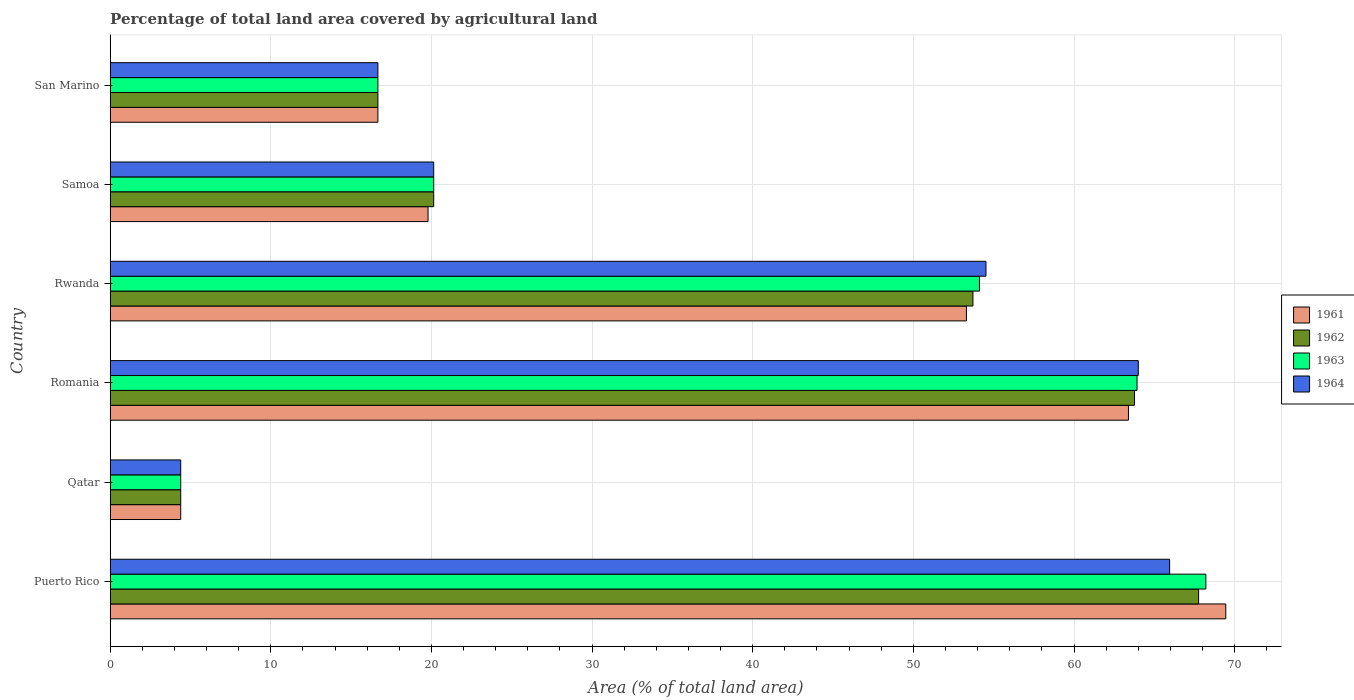Are the number of bars per tick equal to the number of legend labels?
Your answer should be compact. Yes. Are the number of bars on each tick of the Y-axis equal?
Your answer should be compact. Yes. How many bars are there on the 4th tick from the top?
Offer a very short reply. 4. What is the label of the 1st group of bars from the top?
Make the answer very short. San Marino. In how many cases, is the number of bars for a given country not equal to the number of legend labels?
Ensure brevity in your answer.  0. What is the percentage of agricultural land in 1961 in Rwanda?
Your response must be concise. 53.3. Across all countries, what is the maximum percentage of agricultural land in 1961?
Provide a succinct answer. 69.45. Across all countries, what is the minimum percentage of agricultural land in 1964?
Provide a succinct answer. 4.39. In which country was the percentage of agricultural land in 1964 maximum?
Your answer should be compact. Puerto Rico. In which country was the percentage of agricultural land in 1964 minimum?
Make the answer very short. Qatar. What is the total percentage of agricultural land in 1962 in the graph?
Your answer should be compact. 226.43. What is the difference between the percentage of agricultural land in 1962 in Puerto Rico and that in Romania?
Give a very brief answer. 3.99. What is the difference between the percentage of agricultural land in 1961 in Romania and the percentage of agricultural land in 1964 in Samoa?
Provide a short and direct response. 43.25. What is the average percentage of agricultural land in 1962 per country?
Your answer should be compact. 37.74. What is the difference between the percentage of agricultural land in 1961 and percentage of agricultural land in 1964 in Puerto Rico?
Your answer should be compact. 3.49. What is the ratio of the percentage of agricultural land in 1962 in Romania to that in Rwanda?
Keep it short and to the point. 1.19. Is the difference between the percentage of agricultural land in 1961 in Puerto Rico and Samoa greater than the difference between the percentage of agricultural land in 1964 in Puerto Rico and Samoa?
Make the answer very short. Yes. What is the difference between the highest and the second highest percentage of agricultural land in 1961?
Offer a very short reply. 6.06. What is the difference between the highest and the lowest percentage of agricultural land in 1963?
Your answer should be very brief. 63.81. What does the 1st bar from the top in Qatar represents?
Make the answer very short. 1964. What does the 1st bar from the bottom in Rwanda represents?
Give a very brief answer. 1961. How many bars are there?
Offer a very short reply. 24. Are all the bars in the graph horizontal?
Provide a short and direct response. Yes. How many countries are there in the graph?
Provide a short and direct response. 6. What is the difference between two consecutive major ticks on the X-axis?
Offer a very short reply. 10. Are the values on the major ticks of X-axis written in scientific E-notation?
Your answer should be very brief. No. Does the graph contain any zero values?
Give a very brief answer. No. Does the graph contain grids?
Your answer should be compact. Yes. Where does the legend appear in the graph?
Keep it short and to the point. Center right. How many legend labels are there?
Provide a succinct answer. 4. How are the legend labels stacked?
Offer a terse response. Vertical. What is the title of the graph?
Make the answer very short. Percentage of total land area covered by agricultural land. What is the label or title of the X-axis?
Offer a very short reply. Area (% of total land area). What is the label or title of the Y-axis?
Provide a short and direct response. Country. What is the Area (% of total land area) in 1961 in Puerto Rico?
Your response must be concise. 69.45. What is the Area (% of total land area) in 1962 in Puerto Rico?
Ensure brevity in your answer.  67.76. What is the Area (% of total land area) of 1963 in Puerto Rico?
Provide a short and direct response. 68.21. What is the Area (% of total land area) in 1964 in Puerto Rico?
Provide a succinct answer. 65.95. What is the Area (% of total land area) in 1961 in Qatar?
Provide a short and direct response. 4.39. What is the Area (% of total land area) of 1962 in Qatar?
Your answer should be very brief. 4.39. What is the Area (% of total land area) in 1963 in Qatar?
Keep it short and to the point. 4.39. What is the Area (% of total land area) in 1964 in Qatar?
Make the answer very short. 4.39. What is the Area (% of total land area) of 1961 in Romania?
Your answer should be compact. 63.39. What is the Area (% of total land area) of 1962 in Romania?
Your response must be concise. 63.77. What is the Area (% of total land area) in 1963 in Romania?
Your answer should be compact. 63.92. What is the Area (% of total land area) of 1964 in Romania?
Your response must be concise. 64. What is the Area (% of total land area) in 1961 in Rwanda?
Give a very brief answer. 53.3. What is the Area (% of total land area) in 1962 in Rwanda?
Ensure brevity in your answer.  53.71. What is the Area (% of total land area) in 1963 in Rwanda?
Make the answer very short. 54.11. What is the Area (% of total land area) in 1964 in Rwanda?
Give a very brief answer. 54.52. What is the Area (% of total land area) of 1961 in Samoa?
Your response must be concise. 19.79. What is the Area (% of total land area) in 1962 in Samoa?
Your response must be concise. 20.14. What is the Area (% of total land area) in 1963 in Samoa?
Your answer should be compact. 20.14. What is the Area (% of total land area) in 1964 in Samoa?
Provide a short and direct response. 20.14. What is the Area (% of total land area) of 1961 in San Marino?
Make the answer very short. 16.67. What is the Area (% of total land area) of 1962 in San Marino?
Your answer should be very brief. 16.67. What is the Area (% of total land area) in 1963 in San Marino?
Make the answer very short. 16.67. What is the Area (% of total land area) of 1964 in San Marino?
Give a very brief answer. 16.67. Across all countries, what is the maximum Area (% of total land area) in 1961?
Keep it short and to the point. 69.45. Across all countries, what is the maximum Area (% of total land area) in 1962?
Offer a very short reply. 67.76. Across all countries, what is the maximum Area (% of total land area) of 1963?
Your answer should be very brief. 68.21. Across all countries, what is the maximum Area (% of total land area) in 1964?
Your answer should be very brief. 65.95. Across all countries, what is the minimum Area (% of total land area) in 1961?
Offer a very short reply. 4.39. Across all countries, what is the minimum Area (% of total land area) of 1962?
Give a very brief answer. 4.39. Across all countries, what is the minimum Area (% of total land area) in 1963?
Provide a short and direct response. 4.39. Across all countries, what is the minimum Area (% of total land area) of 1964?
Provide a short and direct response. 4.39. What is the total Area (% of total land area) in 1961 in the graph?
Your answer should be compact. 226.99. What is the total Area (% of total land area) in 1962 in the graph?
Provide a succinct answer. 226.43. What is the total Area (% of total land area) in 1963 in the graph?
Offer a terse response. 227.45. What is the total Area (% of total land area) of 1964 in the graph?
Provide a succinct answer. 225.67. What is the difference between the Area (% of total land area) of 1961 in Puerto Rico and that in Qatar?
Offer a very short reply. 65.05. What is the difference between the Area (% of total land area) of 1962 in Puerto Rico and that in Qatar?
Keep it short and to the point. 63.36. What is the difference between the Area (% of total land area) of 1963 in Puerto Rico and that in Qatar?
Your response must be concise. 63.81. What is the difference between the Area (% of total land area) of 1964 in Puerto Rico and that in Qatar?
Offer a very short reply. 61.56. What is the difference between the Area (% of total land area) in 1961 in Puerto Rico and that in Romania?
Your answer should be very brief. 6.06. What is the difference between the Area (% of total land area) of 1962 in Puerto Rico and that in Romania?
Offer a terse response. 3.99. What is the difference between the Area (% of total land area) of 1963 in Puerto Rico and that in Romania?
Give a very brief answer. 4.28. What is the difference between the Area (% of total land area) of 1964 in Puerto Rico and that in Romania?
Provide a short and direct response. 1.95. What is the difference between the Area (% of total land area) in 1961 in Puerto Rico and that in Rwanda?
Your answer should be compact. 16.14. What is the difference between the Area (% of total land area) of 1962 in Puerto Rico and that in Rwanda?
Provide a short and direct response. 14.05. What is the difference between the Area (% of total land area) of 1963 in Puerto Rico and that in Rwanda?
Keep it short and to the point. 14.09. What is the difference between the Area (% of total land area) in 1964 in Puerto Rico and that in Rwanda?
Keep it short and to the point. 11.43. What is the difference between the Area (% of total land area) of 1961 in Puerto Rico and that in Samoa?
Offer a terse response. 49.66. What is the difference between the Area (% of total land area) in 1962 in Puerto Rico and that in Samoa?
Offer a terse response. 47.62. What is the difference between the Area (% of total land area) in 1963 in Puerto Rico and that in Samoa?
Provide a short and direct response. 48.07. What is the difference between the Area (% of total land area) in 1964 in Puerto Rico and that in Samoa?
Make the answer very short. 45.81. What is the difference between the Area (% of total land area) of 1961 in Puerto Rico and that in San Marino?
Make the answer very short. 52.78. What is the difference between the Area (% of total land area) in 1962 in Puerto Rico and that in San Marino?
Give a very brief answer. 51.09. What is the difference between the Area (% of total land area) of 1963 in Puerto Rico and that in San Marino?
Your answer should be compact. 51.54. What is the difference between the Area (% of total land area) in 1964 in Puerto Rico and that in San Marino?
Ensure brevity in your answer.  49.29. What is the difference between the Area (% of total land area) in 1961 in Qatar and that in Romania?
Offer a very short reply. -59. What is the difference between the Area (% of total land area) of 1962 in Qatar and that in Romania?
Ensure brevity in your answer.  -59.37. What is the difference between the Area (% of total land area) in 1963 in Qatar and that in Romania?
Your response must be concise. -59.53. What is the difference between the Area (% of total land area) in 1964 in Qatar and that in Romania?
Keep it short and to the point. -59.61. What is the difference between the Area (% of total land area) in 1961 in Qatar and that in Rwanda?
Provide a succinct answer. -48.91. What is the difference between the Area (% of total land area) of 1962 in Qatar and that in Rwanda?
Offer a terse response. -49.32. What is the difference between the Area (% of total land area) of 1963 in Qatar and that in Rwanda?
Keep it short and to the point. -49.72. What is the difference between the Area (% of total land area) of 1964 in Qatar and that in Rwanda?
Your answer should be compact. -50.13. What is the difference between the Area (% of total land area) in 1961 in Qatar and that in Samoa?
Your answer should be compact. -15.4. What is the difference between the Area (% of total land area) of 1962 in Qatar and that in Samoa?
Offer a terse response. -15.75. What is the difference between the Area (% of total land area) of 1963 in Qatar and that in Samoa?
Make the answer very short. -15.75. What is the difference between the Area (% of total land area) of 1964 in Qatar and that in Samoa?
Offer a very short reply. -15.75. What is the difference between the Area (% of total land area) in 1961 in Qatar and that in San Marino?
Make the answer very short. -12.27. What is the difference between the Area (% of total land area) in 1962 in Qatar and that in San Marino?
Make the answer very short. -12.27. What is the difference between the Area (% of total land area) in 1963 in Qatar and that in San Marino?
Your answer should be very brief. -12.27. What is the difference between the Area (% of total land area) of 1964 in Qatar and that in San Marino?
Your response must be concise. -12.27. What is the difference between the Area (% of total land area) in 1961 in Romania and that in Rwanda?
Your response must be concise. 10.09. What is the difference between the Area (% of total land area) of 1962 in Romania and that in Rwanda?
Your answer should be compact. 10.06. What is the difference between the Area (% of total land area) of 1963 in Romania and that in Rwanda?
Make the answer very short. 9.81. What is the difference between the Area (% of total land area) in 1964 in Romania and that in Rwanda?
Your answer should be very brief. 9.48. What is the difference between the Area (% of total land area) in 1961 in Romania and that in Samoa?
Provide a short and direct response. 43.6. What is the difference between the Area (% of total land area) in 1962 in Romania and that in Samoa?
Provide a succinct answer. 43.63. What is the difference between the Area (% of total land area) of 1963 in Romania and that in Samoa?
Give a very brief answer. 43.78. What is the difference between the Area (% of total land area) in 1964 in Romania and that in Samoa?
Your answer should be compact. 43.86. What is the difference between the Area (% of total land area) of 1961 in Romania and that in San Marino?
Offer a very short reply. 46.72. What is the difference between the Area (% of total land area) of 1962 in Romania and that in San Marino?
Your answer should be compact. 47.1. What is the difference between the Area (% of total land area) in 1963 in Romania and that in San Marino?
Give a very brief answer. 47.26. What is the difference between the Area (% of total land area) of 1964 in Romania and that in San Marino?
Give a very brief answer. 47.33. What is the difference between the Area (% of total land area) in 1961 in Rwanda and that in Samoa?
Keep it short and to the point. 33.52. What is the difference between the Area (% of total land area) of 1962 in Rwanda and that in Samoa?
Provide a short and direct response. 33.57. What is the difference between the Area (% of total land area) in 1963 in Rwanda and that in Samoa?
Ensure brevity in your answer.  33.97. What is the difference between the Area (% of total land area) in 1964 in Rwanda and that in Samoa?
Make the answer very short. 34.38. What is the difference between the Area (% of total land area) of 1961 in Rwanda and that in San Marino?
Your answer should be compact. 36.64. What is the difference between the Area (% of total land area) in 1962 in Rwanda and that in San Marino?
Your answer should be compact. 37.04. What is the difference between the Area (% of total land area) in 1963 in Rwanda and that in San Marino?
Ensure brevity in your answer.  37.45. What is the difference between the Area (% of total land area) of 1964 in Rwanda and that in San Marino?
Keep it short and to the point. 37.85. What is the difference between the Area (% of total land area) of 1961 in Samoa and that in San Marino?
Offer a very short reply. 3.12. What is the difference between the Area (% of total land area) in 1962 in Samoa and that in San Marino?
Give a very brief answer. 3.47. What is the difference between the Area (% of total land area) in 1963 in Samoa and that in San Marino?
Give a very brief answer. 3.47. What is the difference between the Area (% of total land area) of 1964 in Samoa and that in San Marino?
Your answer should be compact. 3.47. What is the difference between the Area (% of total land area) in 1961 in Puerto Rico and the Area (% of total land area) in 1962 in Qatar?
Give a very brief answer. 65.05. What is the difference between the Area (% of total land area) in 1961 in Puerto Rico and the Area (% of total land area) in 1963 in Qatar?
Give a very brief answer. 65.05. What is the difference between the Area (% of total land area) of 1961 in Puerto Rico and the Area (% of total land area) of 1964 in Qatar?
Your answer should be very brief. 65.05. What is the difference between the Area (% of total land area) of 1962 in Puerto Rico and the Area (% of total land area) of 1963 in Qatar?
Provide a succinct answer. 63.36. What is the difference between the Area (% of total land area) in 1962 in Puerto Rico and the Area (% of total land area) in 1964 in Qatar?
Your response must be concise. 63.36. What is the difference between the Area (% of total land area) in 1963 in Puerto Rico and the Area (% of total land area) in 1964 in Qatar?
Make the answer very short. 63.81. What is the difference between the Area (% of total land area) of 1961 in Puerto Rico and the Area (% of total land area) of 1962 in Romania?
Your answer should be compact. 5.68. What is the difference between the Area (% of total land area) of 1961 in Puerto Rico and the Area (% of total land area) of 1963 in Romania?
Keep it short and to the point. 5.52. What is the difference between the Area (% of total land area) in 1961 in Puerto Rico and the Area (% of total land area) in 1964 in Romania?
Offer a very short reply. 5.45. What is the difference between the Area (% of total land area) of 1962 in Puerto Rico and the Area (% of total land area) of 1963 in Romania?
Offer a terse response. 3.83. What is the difference between the Area (% of total land area) of 1962 in Puerto Rico and the Area (% of total land area) of 1964 in Romania?
Give a very brief answer. 3.76. What is the difference between the Area (% of total land area) of 1963 in Puerto Rico and the Area (% of total land area) of 1964 in Romania?
Provide a succinct answer. 4.21. What is the difference between the Area (% of total land area) in 1961 in Puerto Rico and the Area (% of total land area) in 1962 in Rwanda?
Offer a very short reply. 15.74. What is the difference between the Area (% of total land area) in 1961 in Puerto Rico and the Area (% of total land area) in 1963 in Rwanda?
Offer a terse response. 15.33. What is the difference between the Area (% of total land area) in 1961 in Puerto Rico and the Area (% of total land area) in 1964 in Rwanda?
Your answer should be compact. 14.93. What is the difference between the Area (% of total land area) of 1962 in Puerto Rico and the Area (% of total land area) of 1963 in Rwanda?
Give a very brief answer. 13.64. What is the difference between the Area (% of total land area) of 1962 in Puerto Rico and the Area (% of total land area) of 1964 in Rwanda?
Your answer should be compact. 13.24. What is the difference between the Area (% of total land area) of 1963 in Puerto Rico and the Area (% of total land area) of 1964 in Rwanda?
Make the answer very short. 13.69. What is the difference between the Area (% of total land area) of 1961 in Puerto Rico and the Area (% of total land area) of 1962 in Samoa?
Provide a short and direct response. 49.31. What is the difference between the Area (% of total land area) in 1961 in Puerto Rico and the Area (% of total land area) in 1963 in Samoa?
Make the answer very short. 49.31. What is the difference between the Area (% of total land area) in 1961 in Puerto Rico and the Area (% of total land area) in 1964 in Samoa?
Give a very brief answer. 49.31. What is the difference between the Area (% of total land area) in 1962 in Puerto Rico and the Area (% of total land area) in 1963 in Samoa?
Your answer should be compact. 47.62. What is the difference between the Area (% of total land area) of 1962 in Puerto Rico and the Area (% of total land area) of 1964 in Samoa?
Your response must be concise. 47.62. What is the difference between the Area (% of total land area) in 1963 in Puerto Rico and the Area (% of total land area) in 1964 in Samoa?
Offer a very short reply. 48.07. What is the difference between the Area (% of total land area) of 1961 in Puerto Rico and the Area (% of total land area) of 1962 in San Marino?
Provide a short and direct response. 52.78. What is the difference between the Area (% of total land area) in 1961 in Puerto Rico and the Area (% of total land area) in 1963 in San Marino?
Make the answer very short. 52.78. What is the difference between the Area (% of total land area) of 1961 in Puerto Rico and the Area (% of total land area) of 1964 in San Marino?
Ensure brevity in your answer.  52.78. What is the difference between the Area (% of total land area) of 1962 in Puerto Rico and the Area (% of total land area) of 1963 in San Marino?
Provide a succinct answer. 51.09. What is the difference between the Area (% of total land area) of 1962 in Puerto Rico and the Area (% of total land area) of 1964 in San Marino?
Offer a terse response. 51.09. What is the difference between the Area (% of total land area) of 1963 in Puerto Rico and the Area (% of total land area) of 1964 in San Marino?
Your answer should be very brief. 51.54. What is the difference between the Area (% of total land area) in 1961 in Qatar and the Area (% of total land area) in 1962 in Romania?
Ensure brevity in your answer.  -59.37. What is the difference between the Area (% of total land area) of 1961 in Qatar and the Area (% of total land area) of 1963 in Romania?
Offer a very short reply. -59.53. What is the difference between the Area (% of total land area) in 1961 in Qatar and the Area (% of total land area) in 1964 in Romania?
Your answer should be compact. -59.61. What is the difference between the Area (% of total land area) of 1962 in Qatar and the Area (% of total land area) of 1963 in Romania?
Offer a very short reply. -59.53. What is the difference between the Area (% of total land area) of 1962 in Qatar and the Area (% of total land area) of 1964 in Romania?
Give a very brief answer. -59.61. What is the difference between the Area (% of total land area) of 1963 in Qatar and the Area (% of total land area) of 1964 in Romania?
Give a very brief answer. -59.61. What is the difference between the Area (% of total land area) of 1961 in Qatar and the Area (% of total land area) of 1962 in Rwanda?
Offer a terse response. -49.32. What is the difference between the Area (% of total land area) in 1961 in Qatar and the Area (% of total land area) in 1963 in Rwanda?
Ensure brevity in your answer.  -49.72. What is the difference between the Area (% of total land area) in 1961 in Qatar and the Area (% of total land area) in 1964 in Rwanda?
Provide a succinct answer. -50.13. What is the difference between the Area (% of total land area) of 1962 in Qatar and the Area (% of total land area) of 1963 in Rwanda?
Keep it short and to the point. -49.72. What is the difference between the Area (% of total land area) of 1962 in Qatar and the Area (% of total land area) of 1964 in Rwanda?
Your response must be concise. -50.13. What is the difference between the Area (% of total land area) in 1963 in Qatar and the Area (% of total land area) in 1964 in Rwanda?
Your response must be concise. -50.13. What is the difference between the Area (% of total land area) of 1961 in Qatar and the Area (% of total land area) of 1962 in Samoa?
Your answer should be very brief. -15.75. What is the difference between the Area (% of total land area) of 1961 in Qatar and the Area (% of total land area) of 1963 in Samoa?
Make the answer very short. -15.75. What is the difference between the Area (% of total land area) of 1961 in Qatar and the Area (% of total land area) of 1964 in Samoa?
Offer a terse response. -15.75. What is the difference between the Area (% of total land area) of 1962 in Qatar and the Area (% of total land area) of 1963 in Samoa?
Your response must be concise. -15.75. What is the difference between the Area (% of total land area) of 1962 in Qatar and the Area (% of total land area) of 1964 in Samoa?
Ensure brevity in your answer.  -15.75. What is the difference between the Area (% of total land area) of 1963 in Qatar and the Area (% of total land area) of 1964 in Samoa?
Give a very brief answer. -15.75. What is the difference between the Area (% of total land area) of 1961 in Qatar and the Area (% of total land area) of 1962 in San Marino?
Ensure brevity in your answer.  -12.27. What is the difference between the Area (% of total land area) of 1961 in Qatar and the Area (% of total land area) of 1963 in San Marino?
Ensure brevity in your answer.  -12.27. What is the difference between the Area (% of total land area) of 1961 in Qatar and the Area (% of total land area) of 1964 in San Marino?
Your response must be concise. -12.27. What is the difference between the Area (% of total land area) in 1962 in Qatar and the Area (% of total land area) in 1963 in San Marino?
Offer a very short reply. -12.27. What is the difference between the Area (% of total land area) in 1962 in Qatar and the Area (% of total land area) in 1964 in San Marino?
Your answer should be very brief. -12.27. What is the difference between the Area (% of total land area) in 1963 in Qatar and the Area (% of total land area) in 1964 in San Marino?
Your answer should be compact. -12.27. What is the difference between the Area (% of total land area) in 1961 in Romania and the Area (% of total land area) in 1962 in Rwanda?
Your response must be concise. 9.68. What is the difference between the Area (% of total land area) of 1961 in Romania and the Area (% of total land area) of 1963 in Rwanda?
Give a very brief answer. 9.27. What is the difference between the Area (% of total land area) of 1961 in Romania and the Area (% of total land area) of 1964 in Rwanda?
Your answer should be very brief. 8.87. What is the difference between the Area (% of total land area) of 1962 in Romania and the Area (% of total land area) of 1963 in Rwanda?
Make the answer very short. 9.65. What is the difference between the Area (% of total land area) in 1962 in Romania and the Area (% of total land area) in 1964 in Rwanda?
Provide a short and direct response. 9.25. What is the difference between the Area (% of total land area) of 1963 in Romania and the Area (% of total land area) of 1964 in Rwanda?
Provide a succinct answer. 9.4. What is the difference between the Area (% of total land area) in 1961 in Romania and the Area (% of total land area) in 1962 in Samoa?
Give a very brief answer. 43.25. What is the difference between the Area (% of total land area) in 1961 in Romania and the Area (% of total land area) in 1963 in Samoa?
Give a very brief answer. 43.25. What is the difference between the Area (% of total land area) in 1961 in Romania and the Area (% of total land area) in 1964 in Samoa?
Your answer should be very brief. 43.25. What is the difference between the Area (% of total land area) in 1962 in Romania and the Area (% of total land area) in 1963 in Samoa?
Provide a short and direct response. 43.63. What is the difference between the Area (% of total land area) in 1962 in Romania and the Area (% of total land area) in 1964 in Samoa?
Ensure brevity in your answer.  43.63. What is the difference between the Area (% of total land area) in 1963 in Romania and the Area (% of total land area) in 1964 in Samoa?
Keep it short and to the point. 43.78. What is the difference between the Area (% of total land area) in 1961 in Romania and the Area (% of total land area) in 1962 in San Marino?
Offer a terse response. 46.72. What is the difference between the Area (% of total land area) of 1961 in Romania and the Area (% of total land area) of 1963 in San Marino?
Provide a short and direct response. 46.72. What is the difference between the Area (% of total land area) in 1961 in Romania and the Area (% of total land area) in 1964 in San Marino?
Provide a short and direct response. 46.72. What is the difference between the Area (% of total land area) of 1962 in Romania and the Area (% of total land area) of 1963 in San Marino?
Keep it short and to the point. 47.1. What is the difference between the Area (% of total land area) of 1962 in Romania and the Area (% of total land area) of 1964 in San Marino?
Ensure brevity in your answer.  47.1. What is the difference between the Area (% of total land area) of 1963 in Romania and the Area (% of total land area) of 1964 in San Marino?
Offer a terse response. 47.26. What is the difference between the Area (% of total land area) in 1961 in Rwanda and the Area (% of total land area) in 1962 in Samoa?
Keep it short and to the point. 33.16. What is the difference between the Area (% of total land area) of 1961 in Rwanda and the Area (% of total land area) of 1963 in Samoa?
Give a very brief answer. 33.16. What is the difference between the Area (% of total land area) in 1961 in Rwanda and the Area (% of total land area) in 1964 in Samoa?
Your answer should be very brief. 33.16. What is the difference between the Area (% of total land area) of 1962 in Rwanda and the Area (% of total land area) of 1963 in Samoa?
Give a very brief answer. 33.57. What is the difference between the Area (% of total land area) of 1962 in Rwanda and the Area (% of total land area) of 1964 in Samoa?
Your response must be concise. 33.57. What is the difference between the Area (% of total land area) of 1963 in Rwanda and the Area (% of total land area) of 1964 in Samoa?
Ensure brevity in your answer.  33.97. What is the difference between the Area (% of total land area) of 1961 in Rwanda and the Area (% of total land area) of 1962 in San Marino?
Provide a succinct answer. 36.64. What is the difference between the Area (% of total land area) of 1961 in Rwanda and the Area (% of total land area) of 1963 in San Marino?
Make the answer very short. 36.64. What is the difference between the Area (% of total land area) of 1961 in Rwanda and the Area (% of total land area) of 1964 in San Marino?
Offer a terse response. 36.64. What is the difference between the Area (% of total land area) in 1962 in Rwanda and the Area (% of total land area) in 1963 in San Marino?
Your answer should be compact. 37.04. What is the difference between the Area (% of total land area) of 1962 in Rwanda and the Area (% of total land area) of 1964 in San Marino?
Give a very brief answer. 37.04. What is the difference between the Area (% of total land area) in 1963 in Rwanda and the Area (% of total land area) in 1964 in San Marino?
Offer a terse response. 37.45. What is the difference between the Area (% of total land area) in 1961 in Samoa and the Area (% of total land area) in 1962 in San Marino?
Provide a short and direct response. 3.12. What is the difference between the Area (% of total land area) of 1961 in Samoa and the Area (% of total land area) of 1963 in San Marino?
Offer a terse response. 3.12. What is the difference between the Area (% of total land area) of 1961 in Samoa and the Area (% of total land area) of 1964 in San Marino?
Provide a short and direct response. 3.12. What is the difference between the Area (% of total land area) in 1962 in Samoa and the Area (% of total land area) in 1963 in San Marino?
Ensure brevity in your answer.  3.47. What is the difference between the Area (% of total land area) in 1962 in Samoa and the Area (% of total land area) in 1964 in San Marino?
Offer a very short reply. 3.47. What is the difference between the Area (% of total land area) of 1963 in Samoa and the Area (% of total land area) of 1964 in San Marino?
Ensure brevity in your answer.  3.47. What is the average Area (% of total land area) in 1961 per country?
Your answer should be compact. 37.83. What is the average Area (% of total land area) of 1962 per country?
Provide a succinct answer. 37.74. What is the average Area (% of total land area) in 1963 per country?
Offer a very short reply. 37.91. What is the average Area (% of total land area) of 1964 per country?
Offer a very short reply. 37.61. What is the difference between the Area (% of total land area) in 1961 and Area (% of total land area) in 1962 in Puerto Rico?
Your answer should be compact. 1.69. What is the difference between the Area (% of total land area) in 1961 and Area (% of total land area) in 1963 in Puerto Rico?
Your response must be concise. 1.24. What is the difference between the Area (% of total land area) of 1961 and Area (% of total land area) of 1964 in Puerto Rico?
Give a very brief answer. 3.49. What is the difference between the Area (% of total land area) in 1962 and Area (% of total land area) in 1963 in Puerto Rico?
Keep it short and to the point. -0.45. What is the difference between the Area (% of total land area) of 1962 and Area (% of total land area) of 1964 in Puerto Rico?
Provide a succinct answer. 1.8. What is the difference between the Area (% of total land area) of 1963 and Area (% of total land area) of 1964 in Puerto Rico?
Ensure brevity in your answer.  2.25. What is the difference between the Area (% of total land area) of 1961 and Area (% of total land area) of 1962 in Qatar?
Your answer should be very brief. 0. What is the difference between the Area (% of total land area) of 1961 and Area (% of total land area) of 1963 in Qatar?
Give a very brief answer. 0. What is the difference between the Area (% of total land area) of 1961 and Area (% of total land area) of 1964 in Qatar?
Give a very brief answer. 0. What is the difference between the Area (% of total land area) in 1961 and Area (% of total land area) in 1962 in Romania?
Your answer should be very brief. -0.38. What is the difference between the Area (% of total land area) of 1961 and Area (% of total land area) of 1963 in Romania?
Offer a terse response. -0.53. What is the difference between the Area (% of total land area) in 1961 and Area (% of total land area) in 1964 in Romania?
Your response must be concise. -0.61. What is the difference between the Area (% of total land area) of 1962 and Area (% of total land area) of 1963 in Romania?
Keep it short and to the point. -0.16. What is the difference between the Area (% of total land area) of 1962 and Area (% of total land area) of 1964 in Romania?
Provide a short and direct response. -0.23. What is the difference between the Area (% of total land area) of 1963 and Area (% of total land area) of 1964 in Romania?
Keep it short and to the point. -0.08. What is the difference between the Area (% of total land area) in 1961 and Area (% of total land area) in 1962 in Rwanda?
Make the answer very short. -0.41. What is the difference between the Area (% of total land area) in 1961 and Area (% of total land area) in 1963 in Rwanda?
Provide a succinct answer. -0.81. What is the difference between the Area (% of total land area) in 1961 and Area (% of total land area) in 1964 in Rwanda?
Your response must be concise. -1.22. What is the difference between the Area (% of total land area) of 1962 and Area (% of total land area) of 1963 in Rwanda?
Ensure brevity in your answer.  -0.41. What is the difference between the Area (% of total land area) in 1962 and Area (% of total land area) in 1964 in Rwanda?
Provide a short and direct response. -0.81. What is the difference between the Area (% of total land area) of 1963 and Area (% of total land area) of 1964 in Rwanda?
Offer a terse response. -0.41. What is the difference between the Area (% of total land area) in 1961 and Area (% of total land area) in 1962 in Samoa?
Your response must be concise. -0.35. What is the difference between the Area (% of total land area) in 1961 and Area (% of total land area) in 1963 in Samoa?
Your answer should be compact. -0.35. What is the difference between the Area (% of total land area) of 1961 and Area (% of total land area) of 1964 in Samoa?
Provide a short and direct response. -0.35. What is the difference between the Area (% of total land area) of 1962 and Area (% of total land area) of 1964 in Samoa?
Your answer should be very brief. 0. What is the difference between the Area (% of total land area) of 1961 and Area (% of total land area) of 1962 in San Marino?
Ensure brevity in your answer.  0. What is the difference between the Area (% of total land area) of 1961 and Area (% of total land area) of 1963 in San Marino?
Make the answer very short. 0. What is the difference between the Area (% of total land area) of 1962 and Area (% of total land area) of 1964 in San Marino?
Make the answer very short. 0. What is the ratio of the Area (% of total land area) in 1961 in Puerto Rico to that in Qatar?
Make the answer very short. 15.81. What is the ratio of the Area (% of total land area) of 1962 in Puerto Rico to that in Qatar?
Your answer should be very brief. 15.42. What is the ratio of the Area (% of total land area) in 1963 in Puerto Rico to that in Qatar?
Ensure brevity in your answer.  15.53. What is the ratio of the Area (% of total land area) of 1964 in Puerto Rico to that in Qatar?
Your answer should be compact. 15.01. What is the ratio of the Area (% of total land area) of 1961 in Puerto Rico to that in Romania?
Your answer should be very brief. 1.1. What is the ratio of the Area (% of total land area) of 1962 in Puerto Rico to that in Romania?
Offer a very short reply. 1.06. What is the ratio of the Area (% of total land area) of 1963 in Puerto Rico to that in Romania?
Make the answer very short. 1.07. What is the ratio of the Area (% of total land area) of 1964 in Puerto Rico to that in Romania?
Your answer should be compact. 1.03. What is the ratio of the Area (% of total land area) of 1961 in Puerto Rico to that in Rwanda?
Give a very brief answer. 1.3. What is the ratio of the Area (% of total land area) of 1962 in Puerto Rico to that in Rwanda?
Your answer should be very brief. 1.26. What is the ratio of the Area (% of total land area) in 1963 in Puerto Rico to that in Rwanda?
Offer a terse response. 1.26. What is the ratio of the Area (% of total land area) in 1964 in Puerto Rico to that in Rwanda?
Make the answer very short. 1.21. What is the ratio of the Area (% of total land area) in 1961 in Puerto Rico to that in Samoa?
Provide a succinct answer. 3.51. What is the ratio of the Area (% of total land area) in 1962 in Puerto Rico to that in Samoa?
Keep it short and to the point. 3.36. What is the ratio of the Area (% of total land area) of 1963 in Puerto Rico to that in Samoa?
Make the answer very short. 3.39. What is the ratio of the Area (% of total land area) of 1964 in Puerto Rico to that in Samoa?
Your response must be concise. 3.27. What is the ratio of the Area (% of total land area) in 1961 in Puerto Rico to that in San Marino?
Keep it short and to the point. 4.17. What is the ratio of the Area (% of total land area) in 1962 in Puerto Rico to that in San Marino?
Offer a terse response. 4.07. What is the ratio of the Area (% of total land area) in 1963 in Puerto Rico to that in San Marino?
Ensure brevity in your answer.  4.09. What is the ratio of the Area (% of total land area) in 1964 in Puerto Rico to that in San Marino?
Make the answer very short. 3.96. What is the ratio of the Area (% of total land area) of 1961 in Qatar to that in Romania?
Offer a terse response. 0.07. What is the ratio of the Area (% of total land area) in 1962 in Qatar to that in Romania?
Offer a very short reply. 0.07. What is the ratio of the Area (% of total land area) in 1963 in Qatar to that in Romania?
Keep it short and to the point. 0.07. What is the ratio of the Area (% of total land area) in 1964 in Qatar to that in Romania?
Make the answer very short. 0.07. What is the ratio of the Area (% of total land area) in 1961 in Qatar to that in Rwanda?
Offer a terse response. 0.08. What is the ratio of the Area (% of total land area) of 1962 in Qatar to that in Rwanda?
Give a very brief answer. 0.08. What is the ratio of the Area (% of total land area) in 1963 in Qatar to that in Rwanda?
Offer a very short reply. 0.08. What is the ratio of the Area (% of total land area) of 1964 in Qatar to that in Rwanda?
Provide a succinct answer. 0.08. What is the ratio of the Area (% of total land area) of 1961 in Qatar to that in Samoa?
Offer a very short reply. 0.22. What is the ratio of the Area (% of total land area) in 1962 in Qatar to that in Samoa?
Offer a terse response. 0.22. What is the ratio of the Area (% of total land area) of 1963 in Qatar to that in Samoa?
Offer a very short reply. 0.22. What is the ratio of the Area (% of total land area) of 1964 in Qatar to that in Samoa?
Ensure brevity in your answer.  0.22. What is the ratio of the Area (% of total land area) of 1961 in Qatar to that in San Marino?
Your answer should be very brief. 0.26. What is the ratio of the Area (% of total land area) in 1962 in Qatar to that in San Marino?
Provide a succinct answer. 0.26. What is the ratio of the Area (% of total land area) in 1963 in Qatar to that in San Marino?
Your response must be concise. 0.26. What is the ratio of the Area (% of total land area) in 1964 in Qatar to that in San Marino?
Provide a short and direct response. 0.26. What is the ratio of the Area (% of total land area) in 1961 in Romania to that in Rwanda?
Offer a terse response. 1.19. What is the ratio of the Area (% of total land area) of 1962 in Romania to that in Rwanda?
Provide a short and direct response. 1.19. What is the ratio of the Area (% of total land area) in 1963 in Romania to that in Rwanda?
Your answer should be compact. 1.18. What is the ratio of the Area (% of total land area) in 1964 in Romania to that in Rwanda?
Ensure brevity in your answer.  1.17. What is the ratio of the Area (% of total land area) of 1961 in Romania to that in Samoa?
Make the answer very short. 3.2. What is the ratio of the Area (% of total land area) of 1962 in Romania to that in Samoa?
Provide a succinct answer. 3.17. What is the ratio of the Area (% of total land area) in 1963 in Romania to that in Samoa?
Offer a terse response. 3.17. What is the ratio of the Area (% of total land area) of 1964 in Romania to that in Samoa?
Your answer should be very brief. 3.18. What is the ratio of the Area (% of total land area) of 1961 in Romania to that in San Marino?
Ensure brevity in your answer.  3.8. What is the ratio of the Area (% of total land area) in 1962 in Romania to that in San Marino?
Offer a terse response. 3.83. What is the ratio of the Area (% of total land area) of 1963 in Romania to that in San Marino?
Your response must be concise. 3.84. What is the ratio of the Area (% of total land area) in 1964 in Romania to that in San Marino?
Give a very brief answer. 3.84. What is the ratio of the Area (% of total land area) in 1961 in Rwanda to that in Samoa?
Your answer should be compact. 2.69. What is the ratio of the Area (% of total land area) in 1962 in Rwanda to that in Samoa?
Offer a terse response. 2.67. What is the ratio of the Area (% of total land area) of 1963 in Rwanda to that in Samoa?
Offer a very short reply. 2.69. What is the ratio of the Area (% of total land area) of 1964 in Rwanda to that in Samoa?
Offer a terse response. 2.71. What is the ratio of the Area (% of total land area) of 1961 in Rwanda to that in San Marino?
Your response must be concise. 3.2. What is the ratio of the Area (% of total land area) of 1962 in Rwanda to that in San Marino?
Your answer should be compact. 3.22. What is the ratio of the Area (% of total land area) of 1963 in Rwanda to that in San Marino?
Give a very brief answer. 3.25. What is the ratio of the Area (% of total land area) in 1964 in Rwanda to that in San Marino?
Your response must be concise. 3.27. What is the ratio of the Area (% of total land area) in 1961 in Samoa to that in San Marino?
Give a very brief answer. 1.19. What is the ratio of the Area (% of total land area) in 1962 in Samoa to that in San Marino?
Offer a very short reply. 1.21. What is the ratio of the Area (% of total land area) in 1963 in Samoa to that in San Marino?
Keep it short and to the point. 1.21. What is the ratio of the Area (% of total land area) of 1964 in Samoa to that in San Marino?
Provide a short and direct response. 1.21. What is the difference between the highest and the second highest Area (% of total land area) in 1961?
Offer a very short reply. 6.06. What is the difference between the highest and the second highest Area (% of total land area) of 1962?
Keep it short and to the point. 3.99. What is the difference between the highest and the second highest Area (% of total land area) in 1963?
Make the answer very short. 4.28. What is the difference between the highest and the second highest Area (% of total land area) of 1964?
Offer a terse response. 1.95. What is the difference between the highest and the lowest Area (% of total land area) in 1961?
Offer a terse response. 65.05. What is the difference between the highest and the lowest Area (% of total land area) of 1962?
Your answer should be very brief. 63.36. What is the difference between the highest and the lowest Area (% of total land area) of 1963?
Make the answer very short. 63.81. What is the difference between the highest and the lowest Area (% of total land area) in 1964?
Ensure brevity in your answer.  61.56. 